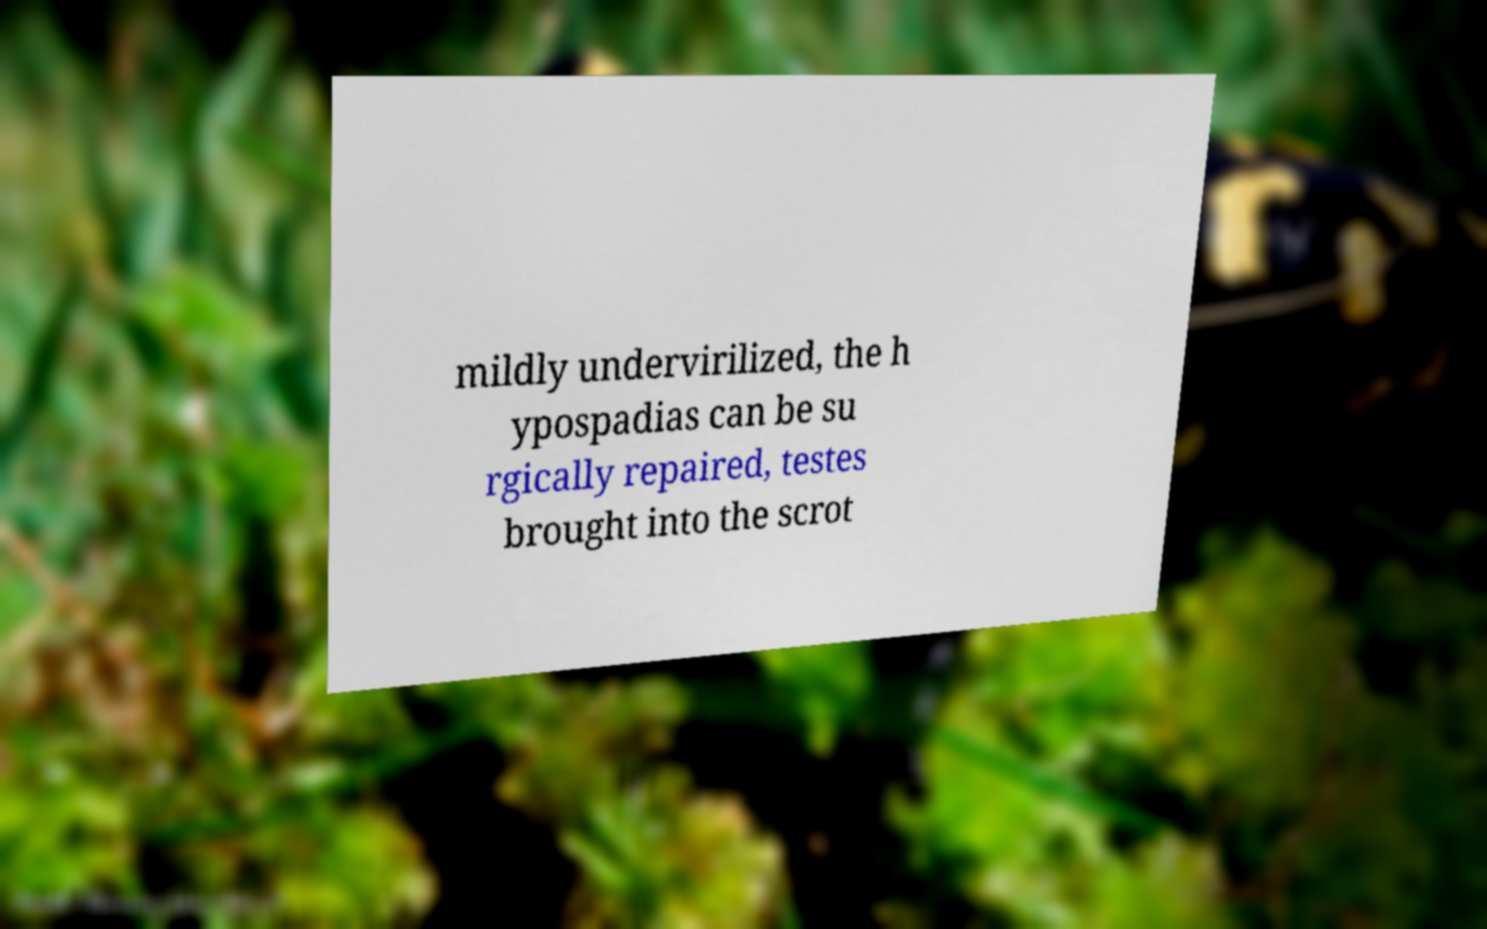There's text embedded in this image that I need extracted. Can you transcribe it verbatim? mildly undervirilized, the h ypospadias can be su rgically repaired, testes brought into the scrot 